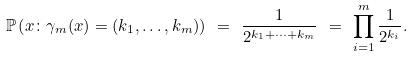<formula> <loc_0><loc_0><loc_500><loc_500>\mathbb { P } \left ( { x \colon \gamma _ { m } ( x ) = ( k _ { 1 } , \dots , k _ { m } ) } \right ) \ = \ \frac { 1 } { 2 ^ { k _ { 1 } + \cdots + k _ { m } } } \ = \ \prod _ { i = 1 } ^ { m } \frac { 1 } { 2 ^ { k _ { i } } } .</formula> 